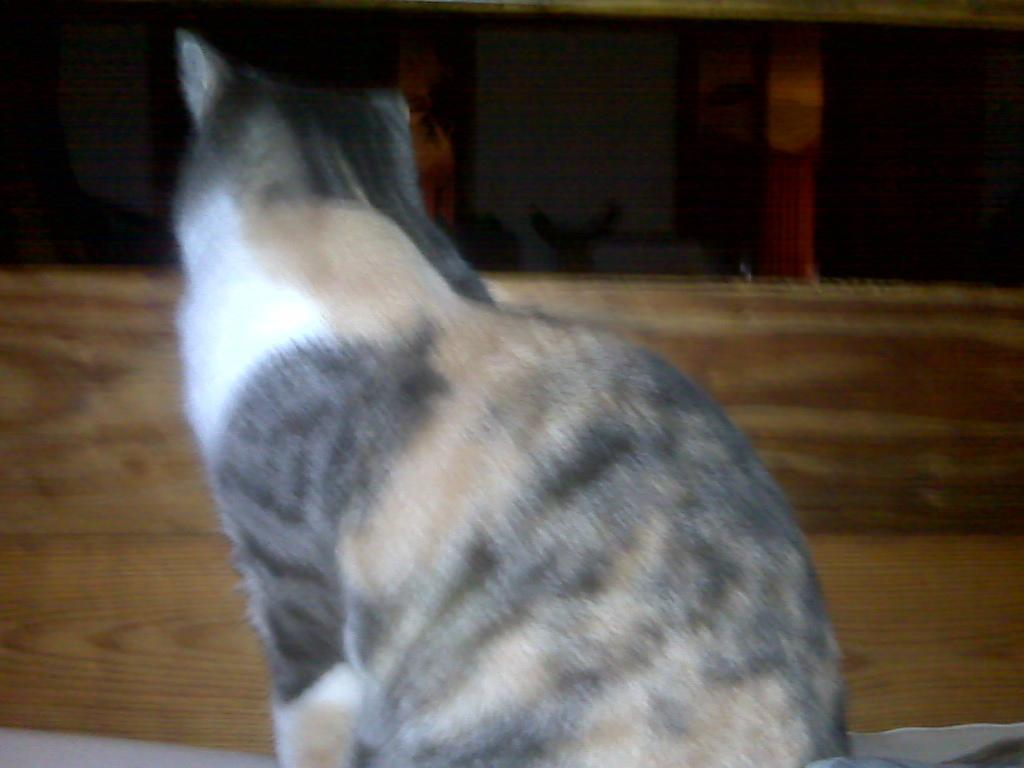What type of animal can be seen in the image, although it is blurred? There is a blurred image of a cat in the image. What material is the sheet in the image made of? There is a wooden sheet in the image. How many wings can be seen on the cat in the image? Cats do not have wings, so there are no wings visible on the cat in the image. Is the cat sleeping in the image? The image is blurred, so it is difficult to determine if the cat is sleeping or not. However, the presence of wings is not mentioned in the facts, so we can confidently say that there are no wings visible on the cat. 